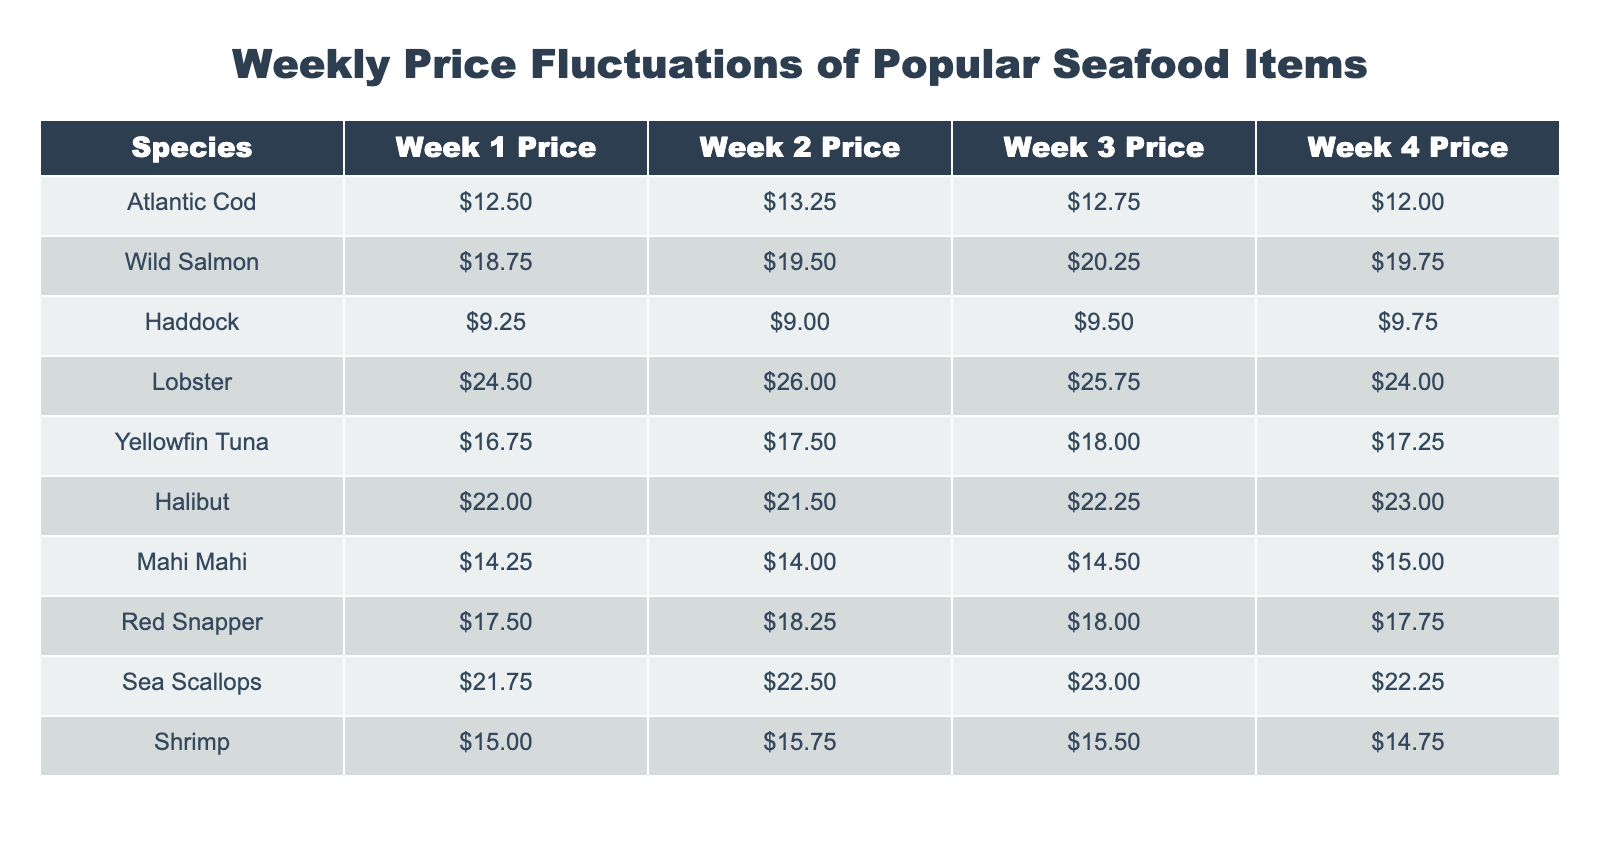What was the price of Wild Salmon in Week 3? The table shows that the price of Wild Salmon in Week 3 is $20.25.
Answer: $20.25 Which seafood item had the highest price in Week 2? Looking at the Week 2 prices, Lobster is the highest at $26.00.
Answer: Lobster What is the average price of Atlantic Cod over the four weeks? To find the average price, add the four prices: ($12.50 + $13.25 + $12.75 + $12.00) = $50.50. Then divide by 4, so $50.50 / 4 = $12.625.
Answer: $12.63 Did the price of Sea Scallops increase in Week 3 compared to Week 2? The price of Sea Scallops was $22.50 in Week 2 and increased to $23.00 in Week 3, so yes, it did increase.
Answer: Yes What was the total price of Shrimp over all four weeks? The prices of Shrimp are $15.00, $15.75, $15.50, and $14.75. Adding these gives $15.00 + $15.75 + $15.50 + $14.75 = $61.00.
Answer: $61.00 Which seafood item saw the most significant price drop from Week 1 to Week 4? Comparing the prices, Lobster dropped from $24.50 in Week 1 to $24.00 in Week 4, which is a decrease of $0.50. Haddock also dropped from $9.25 to $9.75, which is an overall increase. Therefore, Lobster had the most significant drop.
Answer: Lobster In Week 1, which item had a price just below $15.00? In Week 1, both Mahi Mahi at $14.25 and Shrimp at $15.00 were priced below $15.00.
Answer: Mahi Mahi and Shrimp What is the difference in price of Yellowfin Tuna between Week 1 and Week 4? Yellowfin Tuna was priced at $16.75 in Week 1 and $17.25 in Week 4. To find the difference, subtract: $17.25 - $16.75 = $0.50.
Answer: $0.50 Is the average price of Haddock higher than $9.50 across the four weeks? The week prices for Haddock are $9.25, $9.00, $9.50, and $9.75. Adding them gives $9.25 + $9.00 + $9.50 + $9.75 = $37.50. Dividing by 4, the average is $37.50 / 4 = $9.375, which is lower than $9.50.
Answer: No 